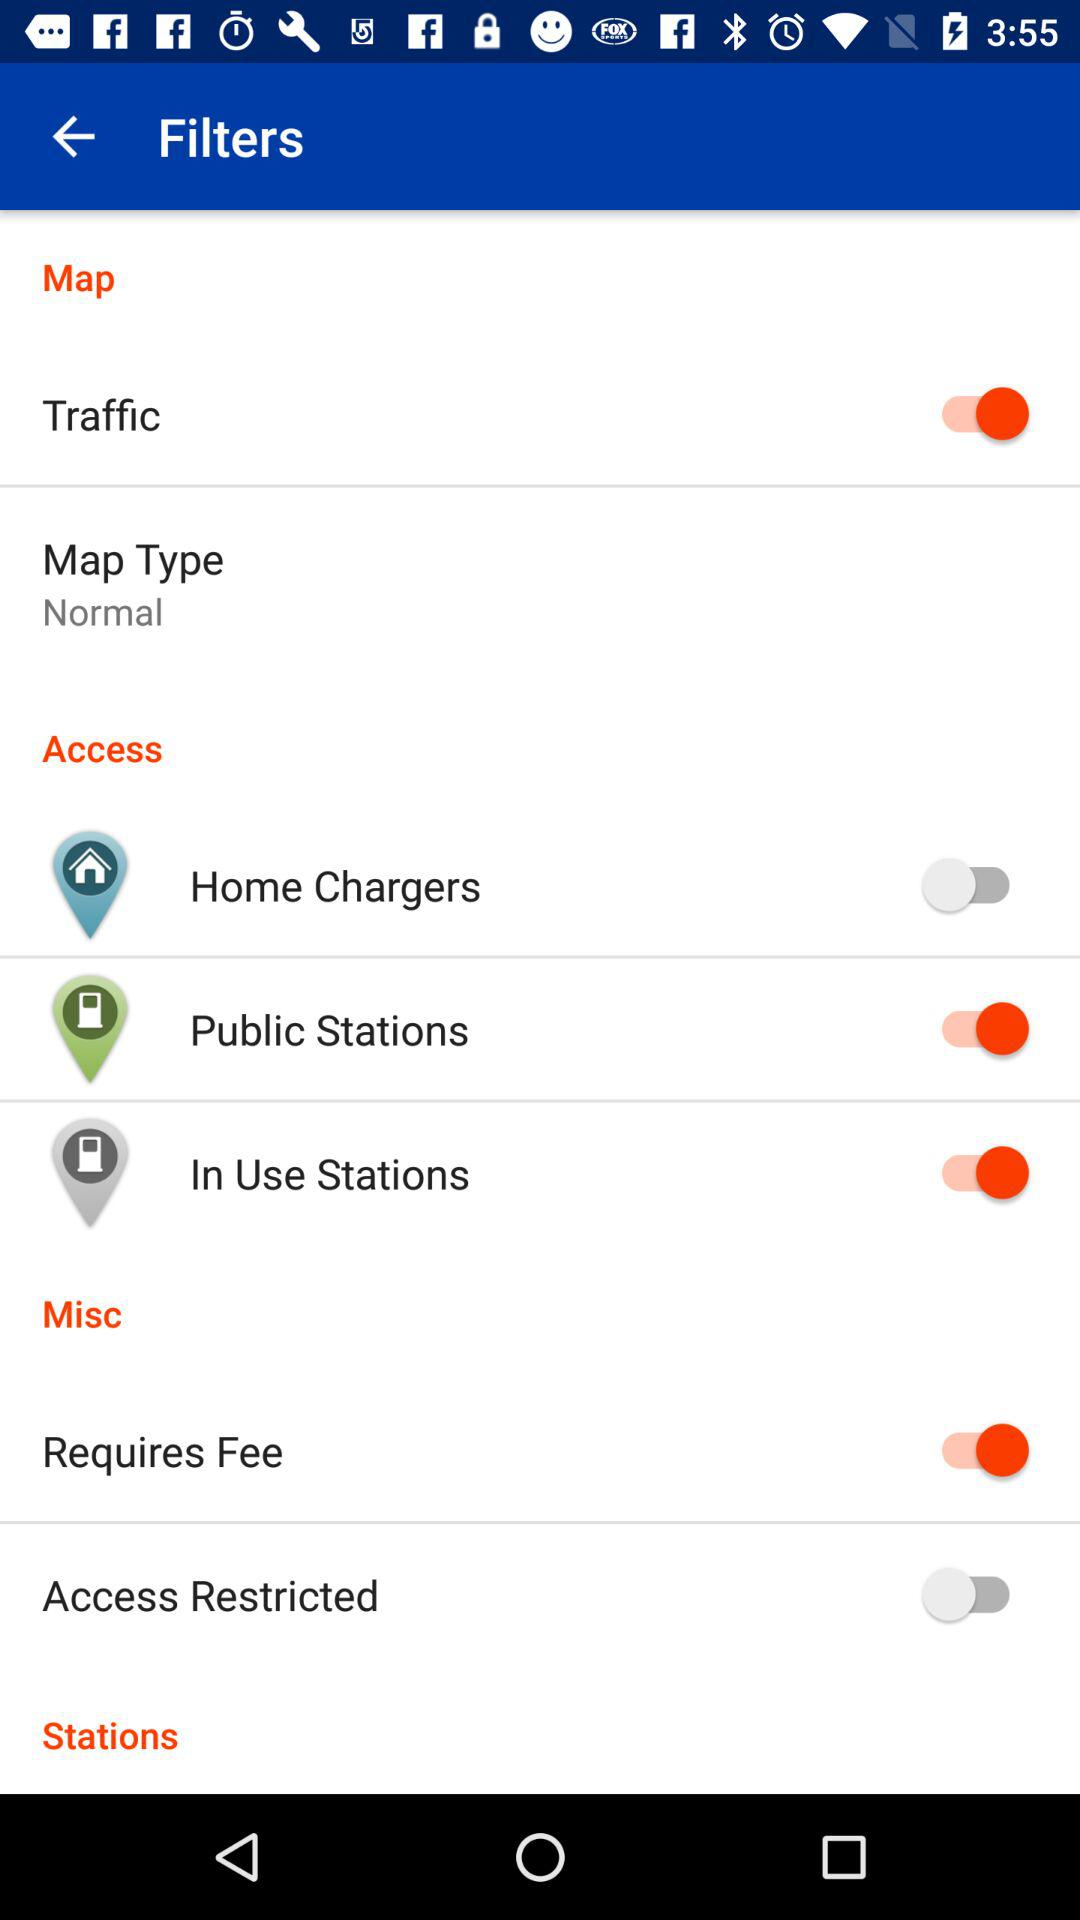What is the map type? The map type is "Normal". 